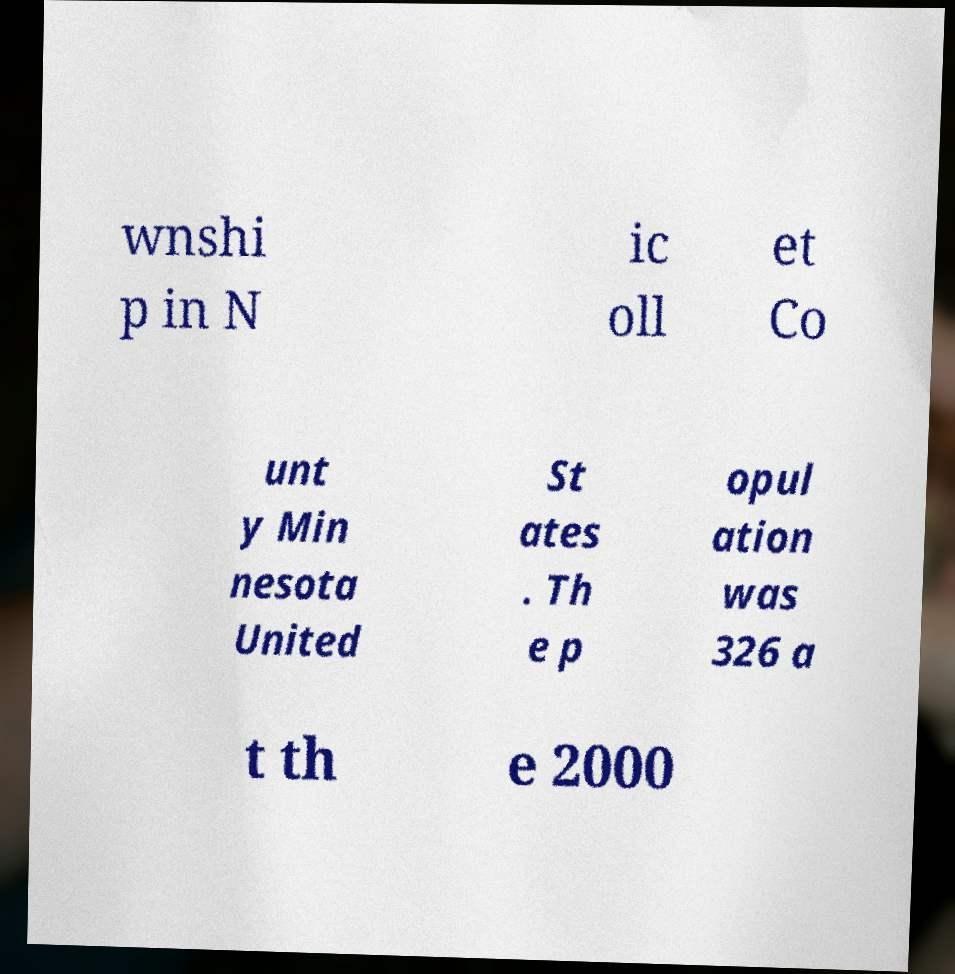Could you assist in decoding the text presented in this image and type it out clearly? wnshi p in N ic oll et Co unt y Min nesota United St ates . Th e p opul ation was 326 a t th e 2000 